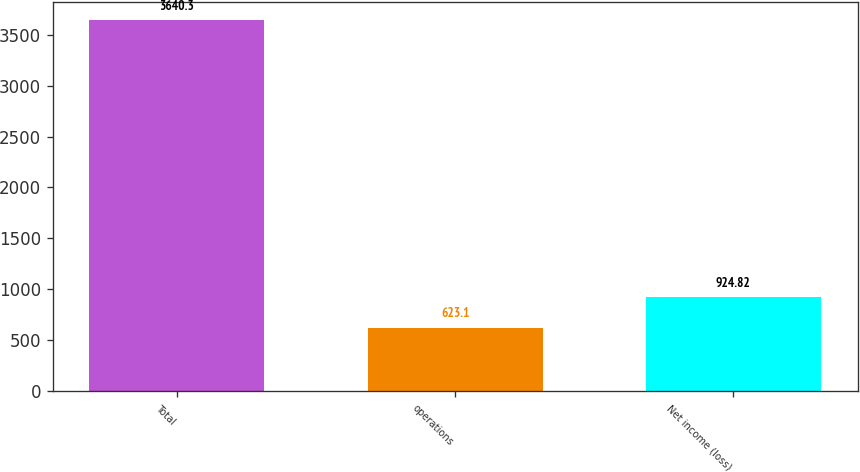<chart> <loc_0><loc_0><loc_500><loc_500><bar_chart><fcel>Total<fcel>operations<fcel>Net income (loss)<nl><fcel>3640.3<fcel>623.1<fcel>924.82<nl></chart> 